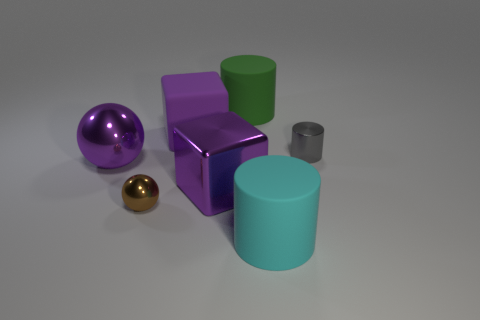Subtract all gray cylinders. How many cylinders are left? 2 Subtract all cubes. How many objects are left? 5 Add 1 brown shiny cylinders. How many objects exist? 8 Subtract all green cylinders. How many cylinders are left? 2 Subtract all red cylinders. How many yellow balls are left? 0 Subtract all large matte cylinders. Subtract all tiny cylinders. How many objects are left? 4 Add 6 large green objects. How many large green objects are left? 7 Add 6 large purple cubes. How many large purple cubes exist? 8 Subtract 0 red spheres. How many objects are left? 7 Subtract 3 cylinders. How many cylinders are left? 0 